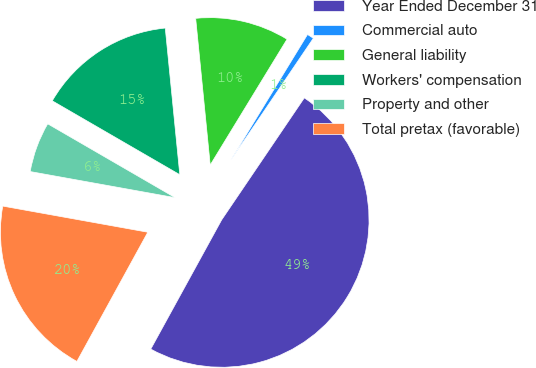Convert chart. <chart><loc_0><loc_0><loc_500><loc_500><pie_chart><fcel>Year Ended December 31<fcel>Commercial auto<fcel>General liability<fcel>Workers' compensation<fcel>Property and other<fcel>Total pretax (favorable)<nl><fcel>48.51%<fcel>0.75%<fcel>10.3%<fcel>15.07%<fcel>5.52%<fcel>19.85%<nl></chart> 